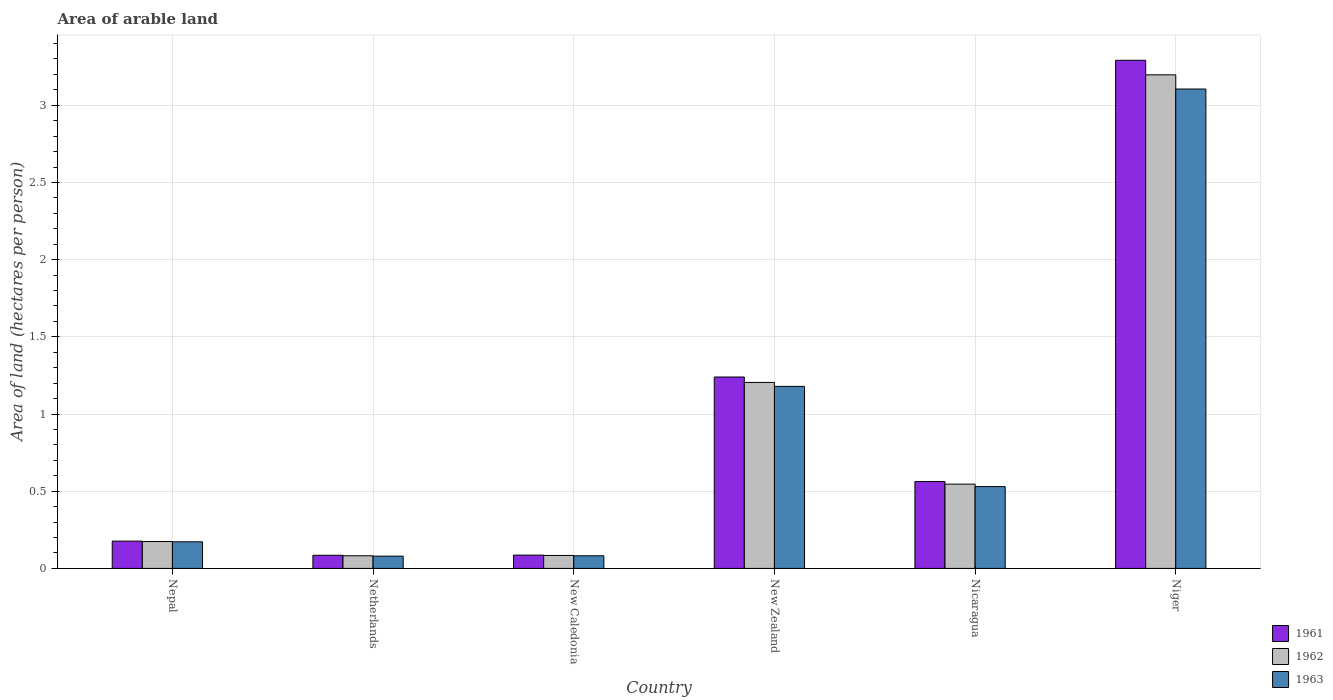How many bars are there on the 4th tick from the left?
Give a very brief answer. 3. How many bars are there on the 6th tick from the right?
Keep it short and to the point. 3. What is the label of the 6th group of bars from the left?
Provide a short and direct response. Niger. What is the total arable land in 1962 in New Zealand?
Offer a very short reply. 1.2. Across all countries, what is the maximum total arable land in 1962?
Your answer should be very brief. 3.2. Across all countries, what is the minimum total arable land in 1963?
Ensure brevity in your answer.  0.08. In which country was the total arable land in 1963 maximum?
Offer a terse response. Niger. In which country was the total arable land in 1963 minimum?
Offer a terse response. Netherlands. What is the total total arable land in 1962 in the graph?
Give a very brief answer. 5.29. What is the difference between the total arable land in 1962 in Netherlands and that in New Zealand?
Provide a short and direct response. -1.12. What is the difference between the total arable land in 1961 in Nicaragua and the total arable land in 1963 in Netherlands?
Make the answer very short. 0.48. What is the average total arable land in 1962 per country?
Provide a succinct answer. 0.88. What is the difference between the total arable land of/in 1962 and total arable land of/in 1961 in Nepal?
Offer a very short reply. -0. In how many countries, is the total arable land in 1961 greater than 0.5 hectares per person?
Your answer should be very brief. 3. What is the ratio of the total arable land in 1961 in Netherlands to that in Niger?
Offer a terse response. 0.03. Is the total arable land in 1963 in New Caledonia less than that in Niger?
Your answer should be very brief. Yes. Is the difference between the total arable land in 1962 in Netherlands and Nicaragua greater than the difference between the total arable land in 1961 in Netherlands and Nicaragua?
Provide a short and direct response. Yes. What is the difference between the highest and the second highest total arable land in 1962?
Your answer should be very brief. -0.66. What is the difference between the highest and the lowest total arable land in 1963?
Your answer should be compact. 3.03. Is the sum of the total arable land in 1963 in Netherlands and Niger greater than the maximum total arable land in 1961 across all countries?
Provide a short and direct response. No. Is it the case that in every country, the sum of the total arable land in 1961 and total arable land in 1963 is greater than the total arable land in 1962?
Keep it short and to the point. Yes. How many bars are there?
Make the answer very short. 18. Are all the bars in the graph horizontal?
Your response must be concise. No. How many countries are there in the graph?
Your answer should be compact. 6. Are the values on the major ticks of Y-axis written in scientific E-notation?
Offer a terse response. No. Does the graph contain any zero values?
Keep it short and to the point. No. Does the graph contain grids?
Offer a very short reply. Yes. How many legend labels are there?
Your answer should be compact. 3. How are the legend labels stacked?
Offer a very short reply. Vertical. What is the title of the graph?
Offer a terse response. Area of arable land. Does "2011" appear as one of the legend labels in the graph?
Offer a very short reply. No. What is the label or title of the Y-axis?
Ensure brevity in your answer.  Area of land (hectares per person). What is the Area of land (hectares per person) in 1961 in Nepal?
Ensure brevity in your answer.  0.18. What is the Area of land (hectares per person) of 1962 in Nepal?
Ensure brevity in your answer.  0.17. What is the Area of land (hectares per person) of 1963 in Nepal?
Your answer should be compact. 0.17. What is the Area of land (hectares per person) in 1961 in Netherlands?
Offer a very short reply. 0.09. What is the Area of land (hectares per person) in 1962 in Netherlands?
Your answer should be compact. 0.08. What is the Area of land (hectares per person) of 1963 in Netherlands?
Give a very brief answer. 0.08. What is the Area of land (hectares per person) in 1961 in New Caledonia?
Your answer should be compact. 0.09. What is the Area of land (hectares per person) in 1962 in New Caledonia?
Your response must be concise. 0.08. What is the Area of land (hectares per person) in 1963 in New Caledonia?
Make the answer very short. 0.08. What is the Area of land (hectares per person) in 1961 in New Zealand?
Provide a succinct answer. 1.24. What is the Area of land (hectares per person) in 1962 in New Zealand?
Ensure brevity in your answer.  1.2. What is the Area of land (hectares per person) of 1963 in New Zealand?
Offer a very short reply. 1.18. What is the Area of land (hectares per person) of 1961 in Nicaragua?
Offer a terse response. 0.56. What is the Area of land (hectares per person) in 1962 in Nicaragua?
Make the answer very short. 0.55. What is the Area of land (hectares per person) in 1963 in Nicaragua?
Your answer should be very brief. 0.53. What is the Area of land (hectares per person) in 1961 in Niger?
Your response must be concise. 3.29. What is the Area of land (hectares per person) of 1962 in Niger?
Make the answer very short. 3.2. What is the Area of land (hectares per person) in 1963 in Niger?
Provide a short and direct response. 3.11. Across all countries, what is the maximum Area of land (hectares per person) of 1961?
Provide a succinct answer. 3.29. Across all countries, what is the maximum Area of land (hectares per person) in 1962?
Your answer should be very brief. 3.2. Across all countries, what is the maximum Area of land (hectares per person) in 1963?
Offer a very short reply. 3.11. Across all countries, what is the minimum Area of land (hectares per person) in 1961?
Ensure brevity in your answer.  0.09. Across all countries, what is the minimum Area of land (hectares per person) of 1962?
Give a very brief answer. 0.08. Across all countries, what is the minimum Area of land (hectares per person) of 1963?
Provide a short and direct response. 0.08. What is the total Area of land (hectares per person) in 1961 in the graph?
Offer a very short reply. 5.44. What is the total Area of land (hectares per person) of 1962 in the graph?
Provide a succinct answer. 5.29. What is the total Area of land (hectares per person) in 1963 in the graph?
Offer a very short reply. 5.15. What is the difference between the Area of land (hectares per person) in 1961 in Nepal and that in Netherlands?
Your answer should be compact. 0.09. What is the difference between the Area of land (hectares per person) in 1962 in Nepal and that in Netherlands?
Provide a short and direct response. 0.09. What is the difference between the Area of land (hectares per person) of 1963 in Nepal and that in Netherlands?
Your answer should be compact. 0.09. What is the difference between the Area of land (hectares per person) in 1961 in Nepal and that in New Caledonia?
Ensure brevity in your answer.  0.09. What is the difference between the Area of land (hectares per person) of 1962 in Nepal and that in New Caledonia?
Offer a very short reply. 0.09. What is the difference between the Area of land (hectares per person) in 1963 in Nepal and that in New Caledonia?
Your answer should be very brief. 0.09. What is the difference between the Area of land (hectares per person) in 1961 in Nepal and that in New Zealand?
Your answer should be very brief. -1.06. What is the difference between the Area of land (hectares per person) in 1962 in Nepal and that in New Zealand?
Give a very brief answer. -1.03. What is the difference between the Area of land (hectares per person) in 1963 in Nepal and that in New Zealand?
Offer a very short reply. -1.01. What is the difference between the Area of land (hectares per person) of 1961 in Nepal and that in Nicaragua?
Keep it short and to the point. -0.39. What is the difference between the Area of land (hectares per person) in 1962 in Nepal and that in Nicaragua?
Your answer should be very brief. -0.37. What is the difference between the Area of land (hectares per person) in 1963 in Nepal and that in Nicaragua?
Ensure brevity in your answer.  -0.36. What is the difference between the Area of land (hectares per person) of 1961 in Nepal and that in Niger?
Provide a succinct answer. -3.11. What is the difference between the Area of land (hectares per person) of 1962 in Nepal and that in Niger?
Give a very brief answer. -3.02. What is the difference between the Area of land (hectares per person) in 1963 in Nepal and that in Niger?
Offer a terse response. -2.93. What is the difference between the Area of land (hectares per person) of 1961 in Netherlands and that in New Caledonia?
Your response must be concise. -0. What is the difference between the Area of land (hectares per person) in 1962 in Netherlands and that in New Caledonia?
Make the answer very short. -0. What is the difference between the Area of land (hectares per person) of 1963 in Netherlands and that in New Caledonia?
Ensure brevity in your answer.  -0. What is the difference between the Area of land (hectares per person) of 1961 in Netherlands and that in New Zealand?
Ensure brevity in your answer.  -1.15. What is the difference between the Area of land (hectares per person) in 1962 in Netherlands and that in New Zealand?
Your answer should be compact. -1.12. What is the difference between the Area of land (hectares per person) in 1963 in Netherlands and that in New Zealand?
Provide a short and direct response. -1.1. What is the difference between the Area of land (hectares per person) in 1961 in Netherlands and that in Nicaragua?
Your answer should be very brief. -0.48. What is the difference between the Area of land (hectares per person) in 1962 in Netherlands and that in Nicaragua?
Offer a terse response. -0.46. What is the difference between the Area of land (hectares per person) in 1963 in Netherlands and that in Nicaragua?
Give a very brief answer. -0.45. What is the difference between the Area of land (hectares per person) of 1961 in Netherlands and that in Niger?
Provide a short and direct response. -3.21. What is the difference between the Area of land (hectares per person) in 1962 in Netherlands and that in Niger?
Provide a succinct answer. -3.12. What is the difference between the Area of land (hectares per person) of 1963 in Netherlands and that in Niger?
Give a very brief answer. -3.03. What is the difference between the Area of land (hectares per person) of 1961 in New Caledonia and that in New Zealand?
Provide a short and direct response. -1.15. What is the difference between the Area of land (hectares per person) in 1962 in New Caledonia and that in New Zealand?
Provide a short and direct response. -1.12. What is the difference between the Area of land (hectares per person) in 1963 in New Caledonia and that in New Zealand?
Your answer should be very brief. -1.1. What is the difference between the Area of land (hectares per person) in 1961 in New Caledonia and that in Nicaragua?
Your answer should be very brief. -0.48. What is the difference between the Area of land (hectares per person) in 1962 in New Caledonia and that in Nicaragua?
Make the answer very short. -0.46. What is the difference between the Area of land (hectares per person) in 1963 in New Caledonia and that in Nicaragua?
Provide a short and direct response. -0.45. What is the difference between the Area of land (hectares per person) in 1961 in New Caledonia and that in Niger?
Keep it short and to the point. -3.21. What is the difference between the Area of land (hectares per person) in 1962 in New Caledonia and that in Niger?
Your response must be concise. -3.11. What is the difference between the Area of land (hectares per person) of 1963 in New Caledonia and that in Niger?
Your response must be concise. -3.02. What is the difference between the Area of land (hectares per person) in 1961 in New Zealand and that in Nicaragua?
Make the answer very short. 0.68. What is the difference between the Area of land (hectares per person) in 1962 in New Zealand and that in Nicaragua?
Your answer should be very brief. 0.66. What is the difference between the Area of land (hectares per person) in 1963 in New Zealand and that in Nicaragua?
Provide a short and direct response. 0.65. What is the difference between the Area of land (hectares per person) in 1961 in New Zealand and that in Niger?
Your response must be concise. -2.05. What is the difference between the Area of land (hectares per person) in 1962 in New Zealand and that in Niger?
Your answer should be compact. -1.99. What is the difference between the Area of land (hectares per person) of 1963 in New Zealand and that in Niger?
Your answer should be compact. -1.93. What is the difference between the Area of land (hectares per person) of 1961 in Nicaragua and that in Niger?
Give a very brief answer. -2.73. What is the difference between the Area of land (hectares per person) in 1962 in Nicaragua and that in Niger?
Your answer should be compact. -2.65. What is the difference between the Area of land (hectares per person) in 1963 in Nicaragua and that in Niger?
Provide a succinct answer. -2.58. What is the difference between the Area of land (hectares per person) of 1961 in Nepal and the Area of land (hectares per person) of 1962 in Netherlands?
Give a very brief answer. 0.1. What is the difference between the Area of land (hectares per person) in 1961 in Nepal and the Area of land (hectares per person) in 1963 in Netherlands?
Your answer should be compact. 0.1. What is the difference between the Area of land (hectares per person) of 1962 in Nepal and the Area of land (hectares per person) of 1963 in Netherlands?
Provide a short and direct response. 0.09. What is the difference between the Area of land (hectares per person) of 1961 in Nepal and the Area of land (hectares per person) of 1962 in New Caledonia?
Offer a very short reply. 0.09. What is the difference between the Area of land (hectares per person) in 1961 in Nepal and the Area of land (hectares per person) in 1963 in New Caledonia?
Offer a very short reply. 0.1. What is the difference between the Area of land (hectares per person) in 1962 in Nepal and the Area of land (hectares per person) in 1963 in New Caledonia?
Provide a short and direct response. 0.09. What is the difference between the Area of land (hectares per person) of 1961 in Nepal and the Area of land (hectares per person) of 1962 in New Zealand?
Offer a terse response. -1.03. What is the difference between the Area of land (hectares per person) in 1961 in Nepal and the Area of land (hectares per person) in 1963 in New Zealand?
Offer a very short reply. -1. What is the difference between the Area of land (hectares per person) of 1962 in Nepal and the Area of land (hectares per person) of 1963 in New Zealand?
Offer a very short reply. -1. What is the difference between the Area of land (hectares per person) of 1961 in Nepal and the Area of land (hectares per person) of 1962 in Nicaragua?
Offer a very short reply. -0.37. What is the difference between the Area of land (hectares per person) in 1961 in Nepal and the Area of land (hectares per person) in 1963 in Nicaragua?
Give a very brief answer. -0.35. What is the difference between the Area of land (hectares per person) in 1962 in Nepal and the Area of land (hectares per person) in 1963 in Nicaragua?
Your answer should be very brief. -0.36. What is the difference between the Area of land (hectares per person) in 1961 in Nepal and the Area of land (hectares per person) in 1962 in Niger?
Provide a succinct answer. -3.02. What is the difference between the Area of land (hectares per person) in 1961 in Nepal and the Area of land (hectares per person) in 1963 in Niger?
Provide a short and direct response. -2.93. What is the difference between the Area of land (hectares per person) of 1962 in Nepal and the Area of land (hectares per person) of 1963 in Niger?
Your answer should be very brief. -2.93. What is the difference between the Area of land (hectares per person) in 1961 in Netherlands and the Area of land (hectares per person) in 1962 in New Caledonia?
Your response must be concise. 0. What is the difference between the Area of land (hectares per person) in 1961 in Netherlands and the Area of land (hectares per person) in 1963 in New Caledonia?
Ensure brevity in your answer.  0. What is the difference between the Area of land (hectares per person) of 1961 in Netherlands and the Area of land (hectares per person) of 1962 in New Zealand?
Keep it short and to the point. -1.12. What is the difference between the Area of land (hectares per person) in 1961 in Netherlands and the Area of land (hectares per person) in 1963 in New Zealand?
Give a very brief answer. -1.09. What is the difference between the Area of land (hectares per person) in 1962 in Netherlands and the Area of land (hectares per person) in 1963 in New Zealand?
Offer a very short reply. -1.1. What is the difference between the Area of land (hectares per person) of 1961 in Netherlands and the Area of land (hectares per person) of 1962 in Nicaragua?
Offer a terse response. -0.46. What is the difference between the Area of land (hectares per person) in 1961 in Netherlands and the Area of land (hectares per person) in 1963 in Nicaragua?
Your answer should be very brief. -0.44. What is the difference between the Area of land (hectares per person) in 1962 in Netherlands and the Area of land (hectares per person) in 1963 in Nicaragua?
Keep it short and to the point. -0.45. What is the difference between the Area of land (hectares per person) of 1961 in Netherlands and the Area of land (hectares per person) of 1962 in Niger?
Your answer should be compact. -3.11. What is the difference between the Area of land (hectares per person) of 1961 in Netherlands and the Area of land (hectares per person) of 1963 in Niger?
Your answer should be very brief. -3.02. What is the difference between the Area of land (hectares per person) of 1962 in Netherlands and the Area of land (hectares per person) of 1963 in Niger?
Give a very brief answer. -3.02. What is the difference between the Area of land (hectares per person) in 1961 in New Caledonia and the Area of land (hectares per person) in 1962 in New Zealand?
Your answer should be compact. -1.12. What is the difference between the Area of land (hectares per person) in 1961 in New Caledonia and the Area of land (hectares per person) in 1963 in New Zealand?
Give a very brief answer. -1.09. What is the difference between the Area of land (hectares per person) in 1962 in New Caledonia and the Area of land (hectares per person) in 1963 in New Zealand?
Offer a terse response. -1.1. What is the difference between the Area of land (hectares per person) in 1961 in New Caledonia and the Area of land (hectares per person) in 1962 in Nicaragua?
Offer a terse response. -0.46. What is the difference between the Area of land (hectares per person) of 1961 in New Caledonia and the Area of land (hectares per person) of 1963 in Nicaragua?
Make the answer very short. -0.44. What is the difference between the Area of land (hectares per person) in 1962 in New Caledonia and the Area of land (hectares per person) in 1963 in Nicaragua?
Make the answer very short. -0.45. What is the difference between the Area of land (hectares per person) in 1961 in New Caledonia and the Area of land (hectares per person) in 1962 in Niger?
Provide a short and direct response. -3.11. What is the difference between the Area of land (hectares per person) of 1961 in New Caledonia and the Area of land (hectares per person) of 1963 in Niger?
Keep it short and to the point. -3.02. What is the difference between the Area of land (hectares per person) of 1962 in New Caledonia and the Area of land (hectares per person) of 1963 in Niger?
Provide a short and direct response. -3.02. What is the difference between the Area of land (hectares per person) in 1961 in New Zealand and the Area of land (hectares per person) in 1962 in Nicaragua?
Ensure brevity in your answer.  0.69. What is the difference between the Area of land (hectares per person) of 1961 in New Zealand and the Area of land (hectares per person) of 1963 in Nicaragua?
Provide a succinct answer. 0.71. What is the difference between the Area of land (hectares per person) in 1962 in New Zealand and the Area of land (hectares per person) in 1963 in Nicaragua?
Give a very brief answer. 0.67. What is the difference between the Area of land (hectares per person) in 1961 in New Zealand and the Area of land (hectares per person) in 1962 in Niger?
Offer a terse response. -1.96. What is the difference between the Area of land (hectares per person) of 1961 in New Zealand and the Area of land (hectares per person) of 1963 in Niger?
Your answer should be very brief. -1.87. What is the difference between the Area of land (hectares per person) in 1962 in New Zealand and the Area of land (hectares per person) in 1963 in Niger?
Ensure brevity in your answer.  -1.9. What is the difference between the Area of land (hectares per person) of 1961 in Nicaragua and the Area of land (hectares per person) of 1962 in Niger?
Your answer should be very brief. -2.63. What is the difference between the Area of land (hectares per person) in 1961 in Nicaragua and the Area of land (hectares per person) in 1963 in Niger?
Your response must be concise. -2.54. What is the difference between the Area of land (hectares per person) of 1962 in Nicaragua and the Area of land (hectares per person) of 1963 in Niger?
Ensure brevity in your answer.  -2.56. What is the average Area of land (hectares per person) in 1961 per country?
Your answer should be very brief. 0.91. What is the average Area of land (hectares per person) of 1962 per country?
Your answer should be compact. 0.88. What is the average Area of land (hectares per person) of 1963 per country?
Provide a short and direct response. 0.86. What is the difference between the Area of land (hectares per person) in 1961 and Area of land (hectares per person) in 1962 in Nepal?
Your answer should be very brief. 0. What is the difference between the Area of land (hectares per person) of 1961 and Area of land (hectares per person) of 1963 in Nepal?
Provide a short and direct response. 0. What is the difference between the Area of land (hectares per person) of 1962 and Area of land (hectares per person) of 1963 in Nepal?
Your answer should be compact. 0. What is the difference between the Area of land (hectares per person) in 1961 and Area of land (hectares per person) in 1962 in Netherlands?
Offer a terse response. 0. What is the difference between the Area of land (hectares per person) in 1961 and Area of land (hectares per person) in 1963 in Netherlands?
Make the answer very short. 0.01. What is the difference between the Area of land (hectares per person) in 1962 and Area of land (hectares per person) in 1963 in Netherlands?
Your response must be concise. 0. What is the difference between the Area of land (hectares per person) of 1961 and Area of land (hectares per person) of 1962 in New Caledonia?
Give a very brief answer. 0. What is the difference between the Area of land (hectares per person) of 1961 and Area of land (hectares per person) of 1963 in New Caledonia?
Keep it short and to the point. 0. What is the difference between the Area of land (hectares per person) of 1962 and Area of land (hectares per person) of 1963 in New Caledonia?
Give a very brief answer. 0. What is the difference between the Area of land (hectares per person) of 1961 and Area of land (hectares per person) of 1962 in New Zealand?
Offer a very short reply. 0.04. What is the difference between the Area of land (hectares per person) in 1961 and Area of land (hectares per person) in 1963 in New Zealand?
Ensure brevity in your answer.  0.06. What is the difference between the Area of land (hectares per person) in 1962 and Area of land (hectares per person) in 1963 in New Zealand?
Provide a succinct answer. 0.03. What is the difference between the Area of land (hectares per person) in 1961 and Area of land (hectares per person) in 1962 in Nicaragua?
Provide a succinct answer. 0.02. What is the difference between the Area of land (hectares per person) in 1961 and Area of land (hectares per person) in 1963 in Nicaragua?
Offer a terse response. 0.03. What is the difference between the Area of land (hectares per person) in 1962 and Area of land (hectares per person) in 1963 in Nicaragua?
Give a very brief answer. 0.02. What is the difference between the Area of land (hectares per person) of 1961 and Area of land (hectares per person) of 1962 in Niger?
Ensure brevity in your answer.  0.09. What is the difference between the Area of land (hectares per person) in 1961 and Area of land (hectares per person) in 1963 in Niger?
Give a very brief answer. 0.19. What is the difference between the Area of land (hectares per person) in 1962 and Area of land (hectares per person) in 1963 in Niger?
Provide a short and direct response. 0.09. What is the ratio of the Area of land (hectares per person) of 1961 in Nepal to that in Netherlands?
Your response must be concise. 2.07. What is the ratio of the Area of land (hectares per person) of 1962 in Nepal to that in Netherlands?
Make the answer very short. 2.13. What is the ratio of the Area of land (hectares per person) of 1963 in Nepal to that in Netherlands?
Offer a very short reply. 2.17. What is the ratio of the Area of land (hectares per person) in 1961 in Nepal to that in New Caledonia?
Keep it short and to the point. 2.05. What is the ratio of the Area of land (hectares per person) of 1962 in Nepal to that in New Caledonia?
Keep it short and to the point. 2.07. What is the ratio of the Area of land (hectares per person) in 1963 in Nepal to that in New Caledonia?
Provide a short and direct response. 2.11. What is the ratio of the Area of land (hectares per person) in 1961 in Nepal to that in New Zealand?
Provide a short and direct response. 0.14. What is the ratio of the Area of land (hectares per person) in 1962 in Nepal to that in New Zealand?
Your answer should be compact. 0.14. What is the ratio of the Area of land (hectares per person) of 1963 in Nepal to that in New Zealand?
Make the answer very short. 0.15. What is the ratio of the Area of land (hectares per person) of 1961 in Nepal to that in Nicaragua?
Your answer should be very brief. 0.31. What is the ratio of the Area of land (hectares per person) of 1962 in Nepal to that in Nicaragua?
Provide a succinct answer. 0.32. What is the ratio of the Area of land (hectares per person) of 1963 in Nepal to that in Nicaragua?
Ensure brevity in your answer.  0.33. What is the ratio of the Area of land (hectares per person) in 1961 in Nepal to that in Niger?
Keep it short and to the point. 0.05. What is the ratio of the Area of land (hectares per person) in 1962 in Nepal to that in Niger?
Your answer should be compact. 0.05. What is the ratio of the Area of land (hectares per person) in 1963 in Nepal to that in Niger?
Offer a terse response. 0.06. What is the ratio of the Area of land (hectares per person) of 1961 in Netherlands to that in New Caledonia?
Provide a succinct answer. 0.99. What is the ratio of the Area of land (hectares per person) of 1962 in Netherlands to that in New Caledonia?
Provide a short and direct response. 0.97. What is the ratio of the Area of land (hectares per person) in 1961 in Netherlands to that in New Zealand?
Your answer should be compact. 0.07. What is the ratio of the Area of land (hectares per person) of 1962 in Netherlands to that in New Zealand?
Keep it short and to the point. 0.07. What is the ratio of the Area of land (hectares per person) of 1963 in Netherlands to that in New Zealand?
Your answer should be very brief. 0.07. What is the ratio of the Area of land (hectares per person) in 1961 in Netherlands to that in Nicaragua?
Offer a very short reply. 0.15. What is the ratio of the Area of land (hectares per person) of 1962 in Netherlands to that in Nicaragua?
Ensure brevity in your answer.  0.15. What is the ratio of the Area of land (hectares per person) in 1963 in Netherlands to that in Nicaragua?
Give a very brief answer. 0.15. What is the ratio of the Area of land (hectares per person) of 1961 in Netherlands to that in Niger?
Ensure brevity in your answer.  0.03. What is the ratio of the Area of land (hectares per person) of 1962 in Netherlands to that in Niger?
Offer a very short reply. 0.03. What is the ratio of the Area of land (hectares per person) of 1963 in Netherlands to that in Niger?
Offer a very short reply. 0.03. What is the ratio of the Area of land (hectares per person) in 1961 in New Caledonia to that in New Zealand?
Your answer should be very brief. 0.07. What is the ratio of the Area of land (hectares per person) of 1962 in New Caledonia to that in New Zealand?
Keep it short and to the point. 0.07. What is the ratio of the Area of land (hectares per person) of 1963 in New Caledonia to that in New Zealand?
Provide a succinct answer. 0.07. What is the ratio of the Area of land (hectares per person) in 1961 in New Caledonia to that in Nicaragua?
Your answer should be compact. 0.15. What is the ratio of the Area of land (hectares per person) in 1962 in New Caledonia to that in Nicaragua?
Offer a terse response. 0.15. What is the ratio of the Area of land (hectares per person) in 1963 in New Caledonia to that in Nicaragua?
Offer a very short reply. 0.15. What is the ratio of the Area of land (hectares per person) in 1961 in New Caledonia to that in Niger?
Provide a short and direct response. 0.03. What is the ratio of the Area of land (hectares per person) of 1962 in New Caledonia to that in Niger?
Keep it short and to the point. 0.03. What is the ratio of the Area of land (hectares per person) in 1963 in New Caledonia to that in Niger?
Offer a terse response. 0.03. What is the ratio of the Area of land (hectares per person) in 1961 in New Zealand to that in Nicaragua?
Ensure brevity in your answer.  2.2. What is the ratio of the Area of land (hectares per person) in 1962 in New Zealand to that in Nicaragua?
Provide a short and direct response. 2.21. What is the ratio of the Area of land (hectares per person) in 1963 in New Zealand to that in Nicaragua?
Your answer should be very brief. 2.22. What is the ratio of the Area of land (hectares per person) of 1961 in New Zealand to that in Niger?
Offer a terse response. 0.38. What is the ratio of the Area of land (hectares per person) in 1962 in New Zealand to that in Niger?
Provide a short and direct response. 0.38. What is the ratio of the Area of land (hectares per person) in 1963 in New Zealand to that in Niger?
Offer a very short reply. 0.38. What is the ratio of the Area of land (hectares per person) of 1961 in Nicaragua to that in Niger?
Ensure brevity in your answer.  0.17. What is the ratio of the Area of land (hectares per person) in 1962 in Nicaragua to that in Niger?
Make the answer very short. 0.17. What is the ratio of the Area of land (hectares per person) in 1963 in Nicaragua to that in Niger?
Your answer should be very brief. 0.17. What is the difference between the highest and the second highest Area of land (hectares per person) in 1961?
Offer a terse response. 2.05. What is the difference between the highest and the second highest Area of land (hectares per person) of 1962?
Offer a terse response. 1.99. What is the difference between the highest and the second highest Area of land (hectares per person) of 1963?
Your answer should be compact. 1.93. What is the difference between the highest and the lowest Area of land (hectares per person) of 1961?
Provide a succinct answer. 3.21. What is the difference between the highest and the lowest Area of land (hectares per person) of 1962?
Give a very brief answer. 3.12. What is the difference between the highest and the lowest Area of land (hectares per person) in 1963?
Your answer should be very brief. 3.03. 